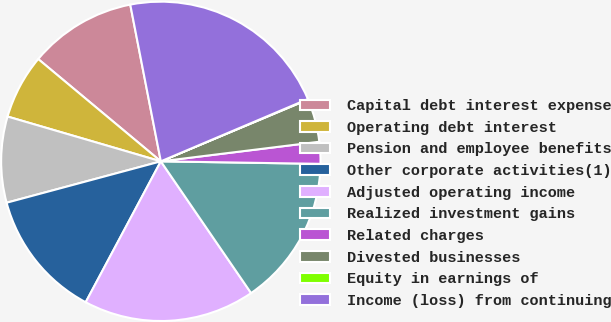Convert chart. <chart><loc_0><loc_0><loc_500><loc_500><pie_chart><fcel>Capital debt interest expense<fcel>Operating debt interest<fcel>Pension and employee benefits<fcel>Other corporate activities(1)<fcel>Adjusted operating income<fcel>Realized investment gains<fcel>Related charges<fcel>Divested businesses<fcel>Equity in earnings of<fcel>Income (loss) from continuing<nl><fcel>10.87%<fcel>6.54%<fcel>8.7%<fcel>13.03%<fcel>17.36%<fcel>15.19%<fcel>2.21%<fcel>4.37%<fcel>0.05%<fcel>21.69%<nl></chart> 